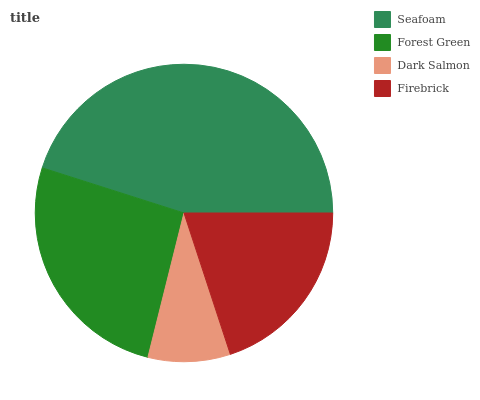Is Dark Salmon the minimum?
Answer yes or no. Yes. Is Seafoam the maximum?
Answer yes or no. Yes. Is Forest Green the minimum?
Answer yes or no. No. Is Forest Green the maximum?
Answer yes or no. No. Is Seafoam greater than Forest Green?
Answer yes or no. Yes. Is Forest Green less than Seafoam?
Answer yes or no. Yes. Is Forest Green greater than Seafoam?
Answer yes or no. No. Is Seafoam less than Forest Green?
Answer yes or no. No. Is Forest Green the high median?
Answer yes or no. Yes. Is Firebrick the low median?
Answer yes or no. Yes. Is Firebrick the high median?
Answer yes or no. No. Is Dark Salmon the low median?
Answer yes or no. No. 